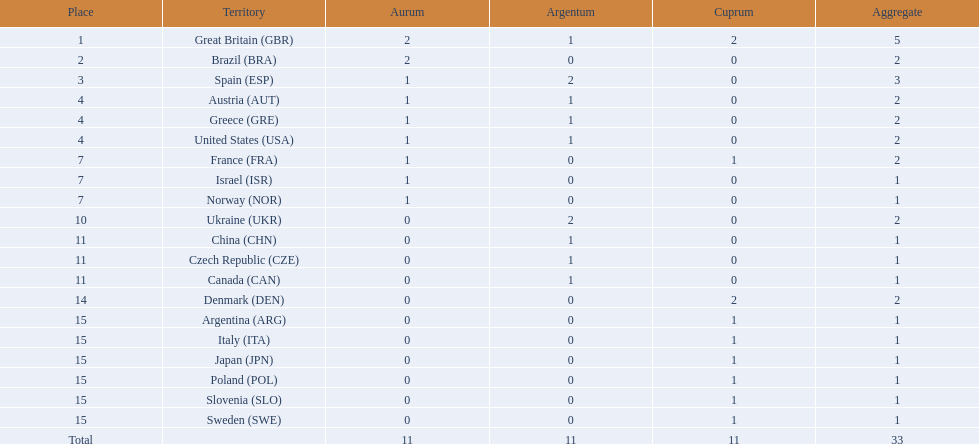How many medals did spain gain 3. Only country that got more medals? Spain (ESP). Could you parse the entire table as a dict? {'header': ['Place', 'Territory', 'Aurum', 'Argentum', 'Cuprum', 'Aggregate'], 'rows': [['1', 'Great Britain\xa0(GBR)', '2', '1', '2', '5'], ['2', 'Brazil\xa0(BRA)', '2', '0', '0', '2'], ['3', 'Spain\xa0(ESP)', '1', '2', '0', '3'], ['4', 'Austria\xa0(AUT)', '1', '1', '0', '2'], ['4', 'Greece\xa0(GRE)', '1', '1', '0', '2'], ['4', 'United States\xa0(USA)', '1', '1', '0', '2'], ['7', 'France\xa0(FRA)', '1', '0', '1', '2'], ['7', 'Israel\xa0(ISR)', '1', '0', '0', '1'], ['7', 'Norway\xa0(NOR)', '1', '0', '0', '1'], ['10', 'Ukraine\xa0(UKR)', '0', '2', '0', '2'], ['11', 'China\xa0(CHN)', '0', '1', '0', '1'], ['11', 'Czech Republic\xa0(CZE)', '0', '1', '0', '1'], ['11', 'Canada\xa0(CAN)', '0', '1', '0', '1'], ['14', 'Denmark\xa0(DEN)', '0', '0', '2', '2'], ['15', 'Argentina\xa0(ARG)', '0', '0', '1', '1'], ['15', 'Italy\xa0(ITA)', '0', '0', '1', '1'], ['15', 'Japan\xa0(JPN)', '0', '0', '1', '1'], ['15', 'Poland\xa0(POL)', '0', '0', '1', '1'], ['15', 'Slovenia\xa0(SLO)', '0', '0', '1', '1'], ['15', 'Sweden\xa0(SWE)', '0', '0', '1', '1'], ['Total', '', '11', '11', '11', '33']]} 